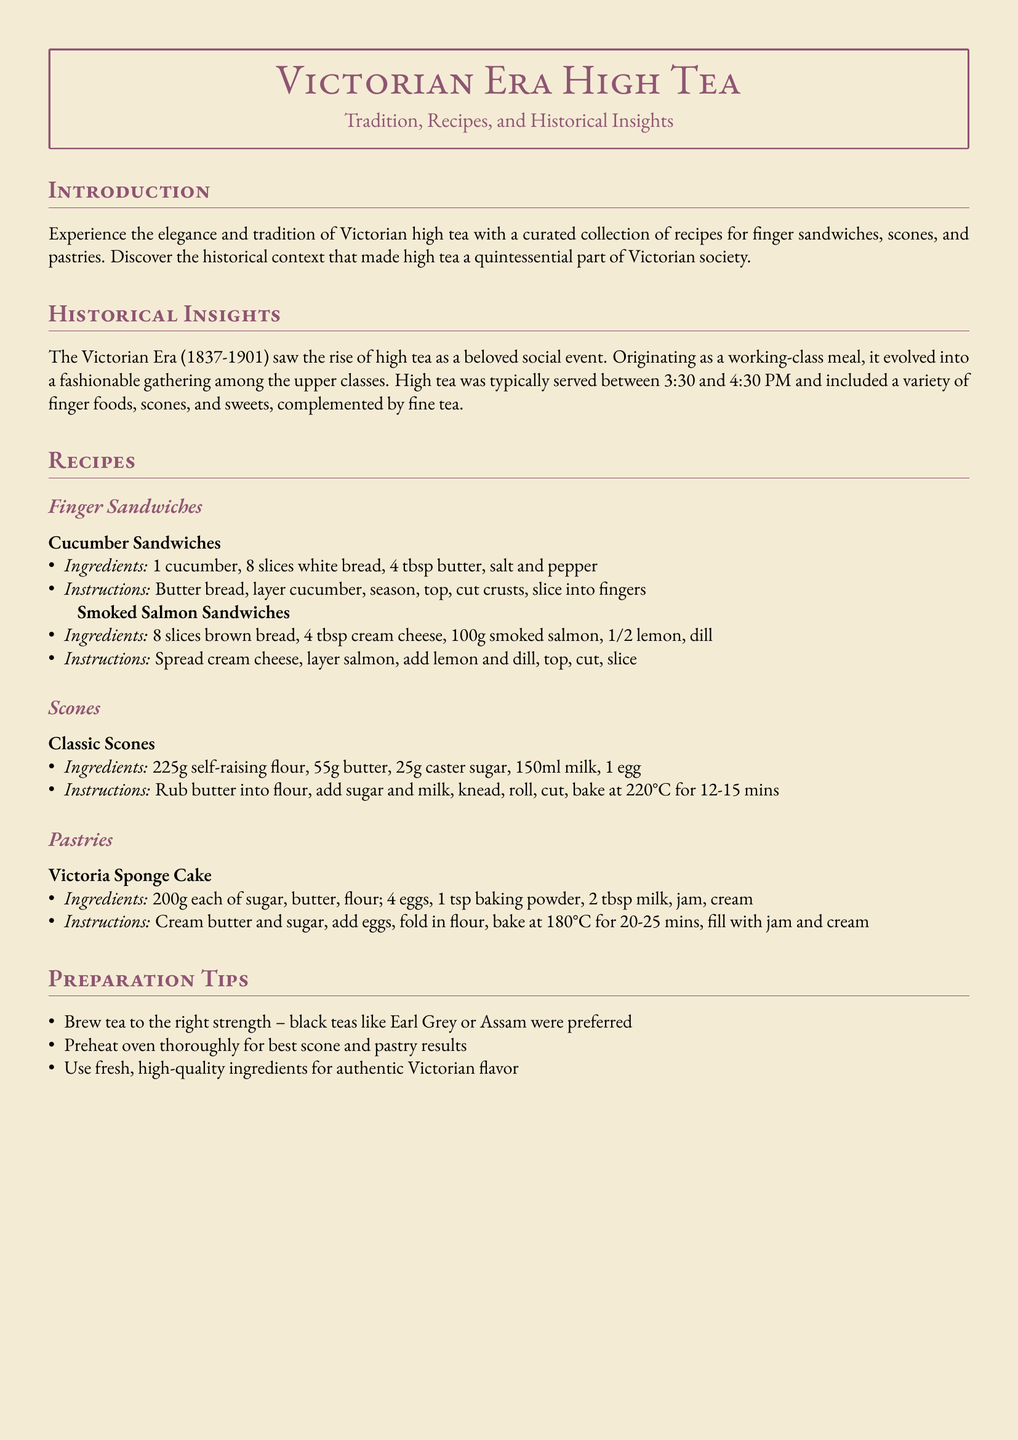what is the time range high tea is typically served? The document specifies that high tea was typically served between 3:30 and 4:30 PM.
Answer: 3:30 and 4:30 PM how many ingredients are listed for Classic Scones? The recipe for Classic Scones includes five ingredients: self-raising flour, butter, caster sugar, milk, and egg.
Answer: 5 what is the main filling of the Victoria Sponge Cake? The document states that the Victoria Sponge Cake is filled with jam and cream.
Answer: jam and cream which type of tea is preferred for brewing? The document mentions that black teas like Earl Grey or Assam were preferred for brewing.
Answer: black teas like Earl Grey or Assam what ingredient is used for buttering the cucumber sandwiches? The recipe indicates that butter is used to butter the bread for the cucumber sandwiches.
Answer: butter how long should the scones be baked for? The document specifies that scones should be baked for 12-15 minutes.
Answer: 12-15 minutes what is used as seasoning in Cucumber Sandwiches? The recipe for Cucumber Sandwiches specifically uses salt and pepper for seasoning.
Answer: salt and pepper how should the butter be prepared for Classic Scones? The instructions indicate that the butter should be rubbed into the flour.
Answer: rubbed into the flour 